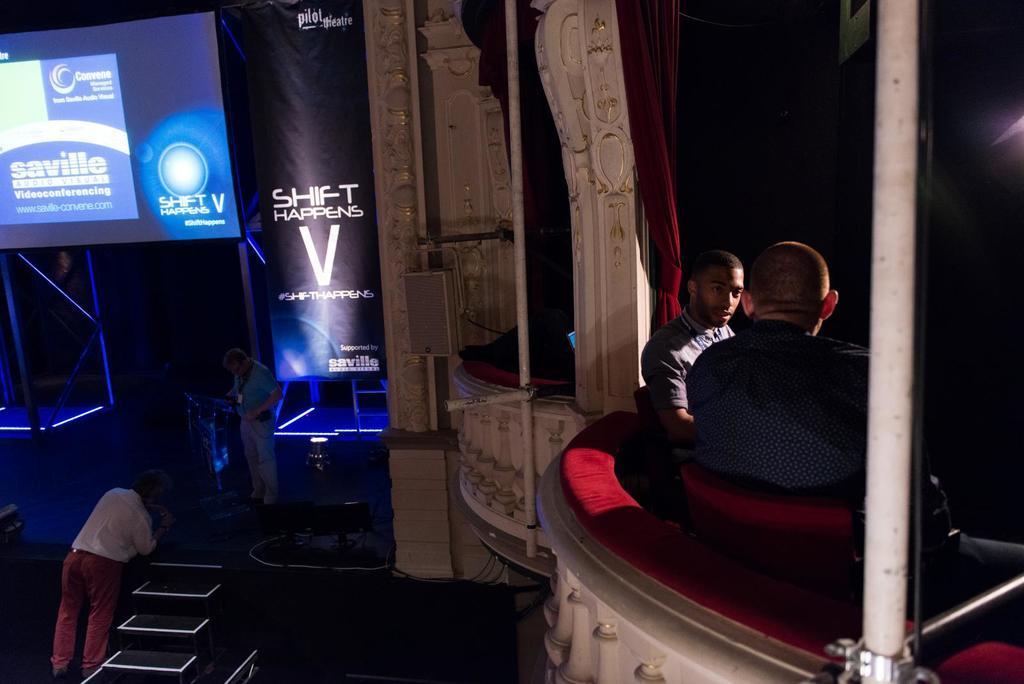In one or two sentences, can you explain what this image depicts? This picture shows two men were sitting in the cars here in the right side. There is a man in the left bottom corner, standing near the steps. We can observe a display screen projector hire. Beside that there is a poster. 